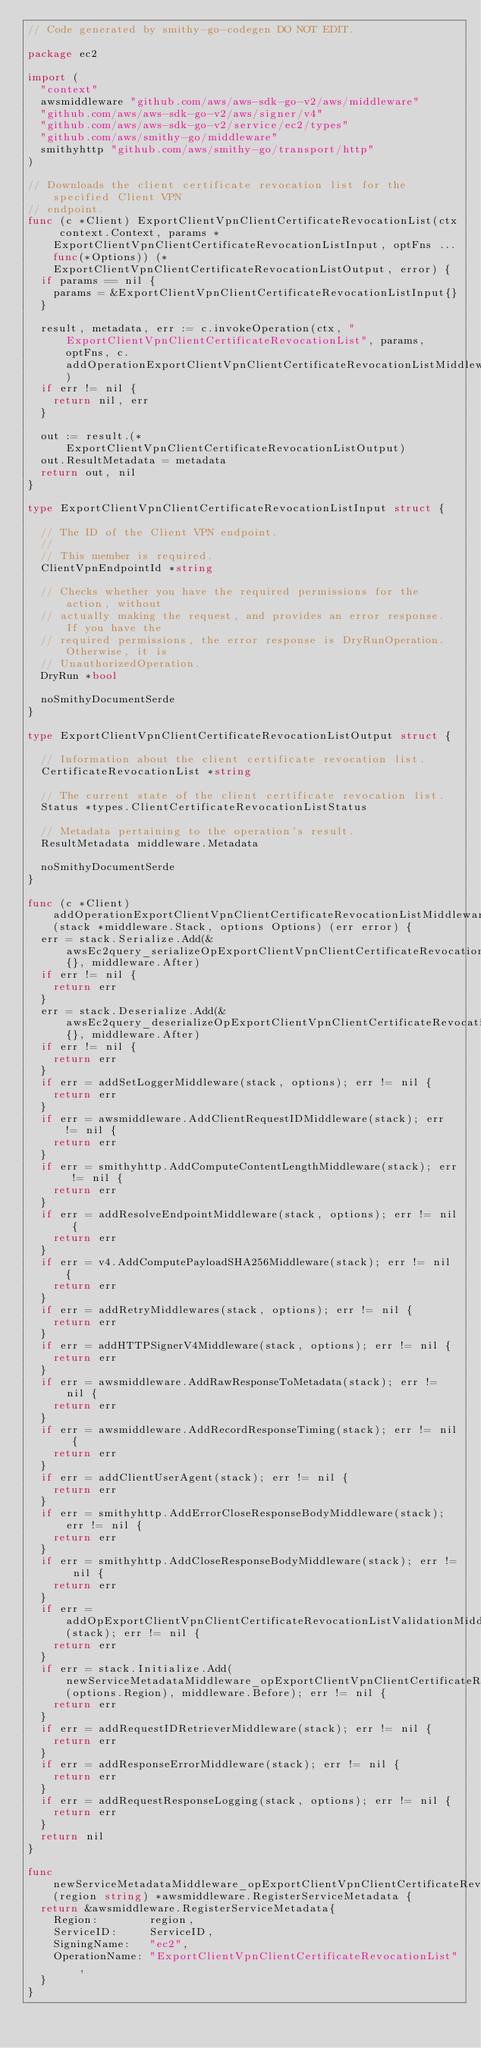Convert code to text. <code><loc_0><loc_0><loc_500><loc_500><_Go_>// Code generated by smithy-go-codegen DO NOT EDIT.

package ec2

import (
	"context"
	awsmiddleware "github.com/aws/aws-sdk-go-v2/aws/middleware"
	"github.com/aws/aws-sdk-go-v2/aws/signer/v4"
	"github.com/aws/aws-sdk-go-v2/service/ec2/types"
	"github.com/aws/smithy-go/middleware"
	smithyhttp "github.com/aws/smithy-go/transport/http"
)

// Downloads the client certificate revocation list for the specified Client VPN
// endpoint.
func (c *Client) ExportClientVpnClientCertificateRevocationList(ctx context.Context, params *ExportClientVpnClientCertificateRevocationListInput, optFns ...func(*Options)) (*ExportClientVpnClientCertificateRevocationListOutput, error) {
	if params == nil {
		params = &ExportClientVpnClientCertificateRevocationListInput{}
	}

	result, metadata, err := c.invokeOperation(ctx, "ExportClientVpnClientCertificateRevocationList", params, optFns, c.addOperationExportClientVpnClientCertificateRevocationListMiddlewares)
	if err != nil {
		return nil, err
	}

	out := result.(*ExportClientVpnClientCertificateRevocationListOutput)
	out.ResultMetadata = metadata
	return out, nil
}

type ExportClientVpnClientCertificateRevocationListInput struct {

	// The ID of the Client VPN endpoint.
	//
	// This member is required.
	ClientVpnEndpointId *string

	// Checks whether you have the required permissions for the action, without
	// actually making the request, and provides an error response. If you have the
	// required permissions, the error response is DryRunOperation. Otherwise, it is
	// UnauthorizedOperation.
	DryRun *bool

	noSmithyDocumentSerde
}

type ExportClientVpnClientCertificateRevocationListOutput struct {

	// Information about the client certificate revocation list.
	CertificateRevocationList *string

	// The current state of the client certificate revocation list.
	Status *types.ClientCertificateRevocationListStatus

	// Metadata pertaining to the operation's result.
	ResultMetadata middleware.Metadata

	noSmithyDocumentSerde
}

func (c *Client) addOperationExportClientVpnClientCertificateRevocationListMiddlewares(stack *middleware.Stack, options Options) (err error) {
	err = stack.Serialize.Add(&awsEc2query_serializeOpExportClientVpnClientCertificateRevocationList{}, middleware.After)
	if err != nil {
		return err
	}
	err = stack.Deserialize.Add(&awsEc2query_deserializeOpExportClientVpnClientCertificateRevocationList{}, middleware.After)
	if err != nil {
		return err
	}
	if err = addSetLoggerMiddleware(stack, options); err != nil {
		return err
	}
	if err = awsmiddleware.AddClientRequestIDMiddleware(stack); err != nil {
		return err
	}
	if err = smithyhttp.AddComputeContentLengthMiddleware(stack); err != nil {
		return err
	}
	if err = addResolveEndpointMiddleware(stack, options); err != nil {
		return err
	}
	if err = v4.AddComputePayloadSHA256Middleware(stack); err != nil {
		return err
	}
	if err = addRetryMiddlewares(stack, options); err != nil {
		return err
	}
	if err = addHTTPSignerV4Middleware(stack, options); err != nil {
		return err
	}
	if err = awsmiddleware.AddRawResponseToMetadata(stack); err != nil {
		return err
	}
	if err = awsmiddleware.AddRecordResponseTiming(stack); err != nil {
		return err
	}
	if err = addClientUserAgent(stack); err != nil {
		return err
	}
	if err = smithyhttp.AddErrorCloseResponseBodyMiddleware(stack); err != nil {
		return err
	}
	if err = smithyhttp.AddCloseResponseBodyMiddleware(stack); err != nil {
		return err
	}
	if err = addOpExportClientVpnClientCertificateRevocationListValidationMiddleware(stack); err != nil {
		return err
	}
	if err = stack.Initialize.Add(newServiceMetadataMiddleware_opExportClientVpnClientCertificateRevocationList(options.Region), middleware.Before); err != nil {
		return err
	}
	if err = addRequestIDRetrieverMiddleware(stack); err != nil {
		return err
	}
	if err = addResponseErrorMiddleware(stack); err != nil {
		return err
	}
	if err = addRequestResponseLogging(stack, options); err != nil {
		return err
	}
	return nil
}

func newServiceMetadataMiddleware_opExportClientVpnClientCertificateRevocationList(region string) *awsmiddleware.RegisterServiceMetadata {
	return &awsmiddleware.RegisterServiceMetadata{
		Region:        region,
		ServiceID:     ServiceID,
		SigningName:   "ec2",
		OperationName: "ExportClientVpnClientCertificateRevocationList",
	}
}
</code> 